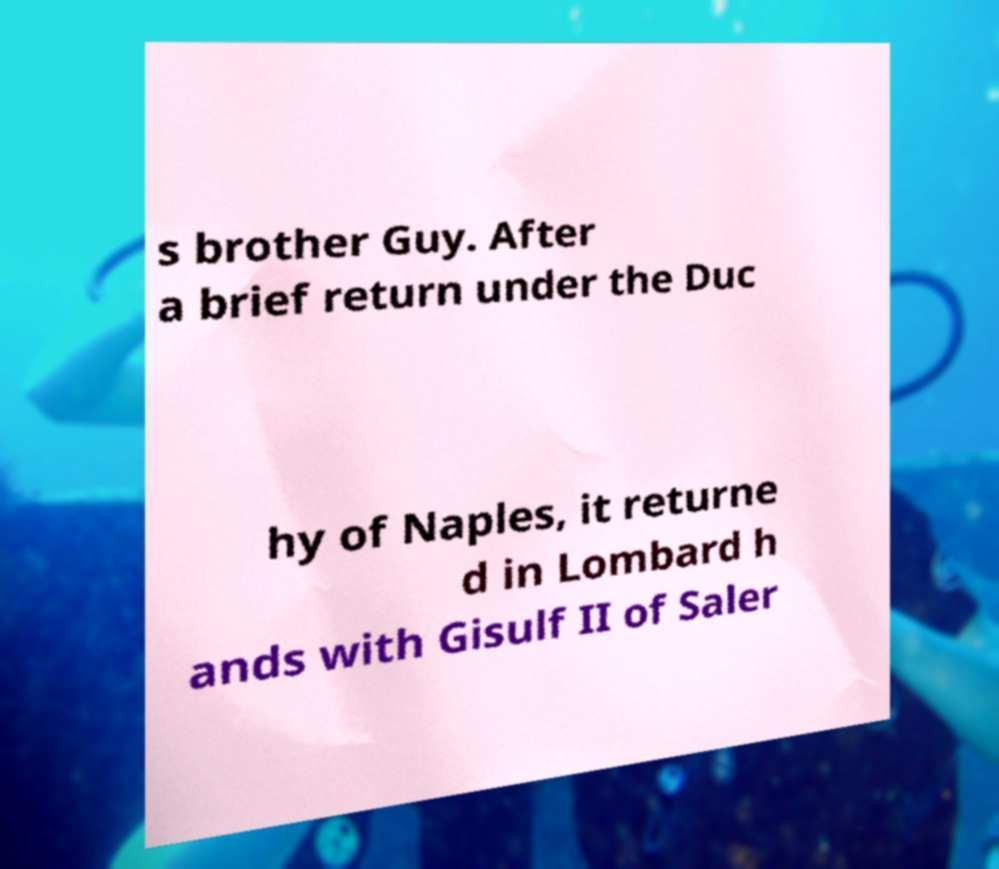Could you extract and type out the text from this image? s brother Guy. After a brief return under the Duc hy of Naples, it returne d in Lombard h ands with Gisulf II of Saler 